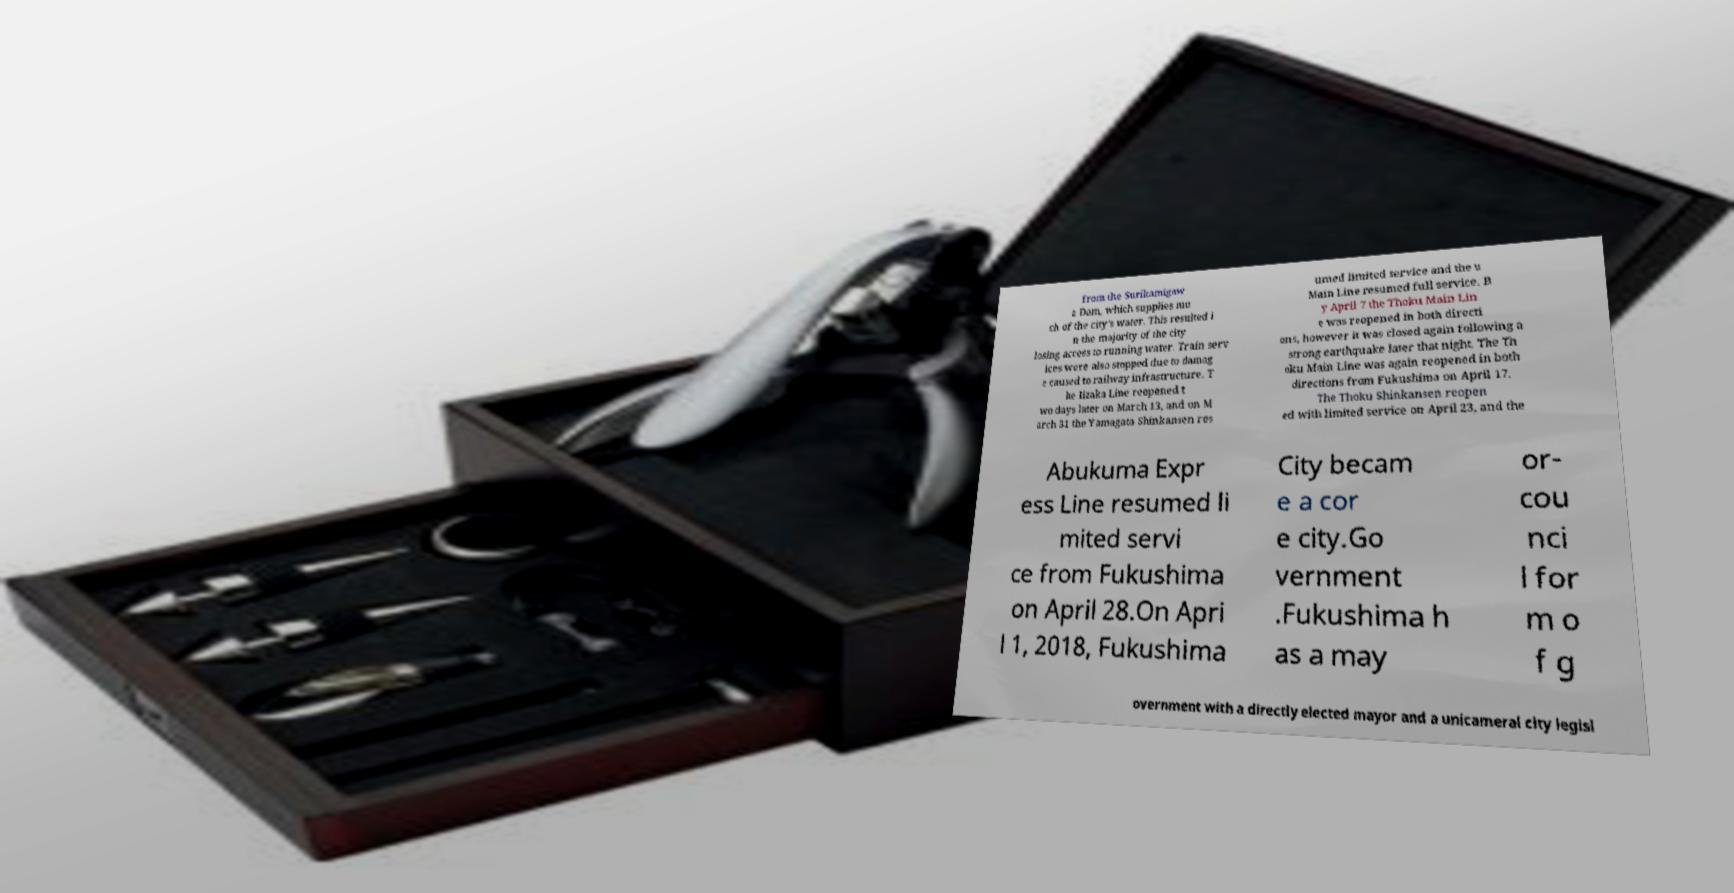Can you read and provide the text displayed in the image?This photo seems to have some interesting text. Can you extract and type it out for me? from the Surikamigaw a Dam, which supplies mu ch of the city's water. This resulted i n the majority of the city losing access to running water. Train serv ices were also stopped due to damag e caused to railway infrastructure. T he Iizaka Line reopened t wo days later on March 13, and on M arch 31 the Yamagata Shinkansen res umed limited service and the u Main Line resumed full service. B y April 7 the Thoku Main Lin e was reopened in both directi ons, however it was closed again following a strong earthquake later that night. The Th oku Main Line was again reopened in both directions from Fukushima on April 17. The Thoku Shinkansen reopen ed with limited service on April 23, and the Abukuma Expr ess Line resumed li mited servi ce from Fukushima on April 28.On Apri l 1, 2018, Fukushima City becam e a cor e city.Go vernment .Fukushima h as a may or- cou nci l for m o f g overnment with a directly elected mayor and a unicameral city legisl 